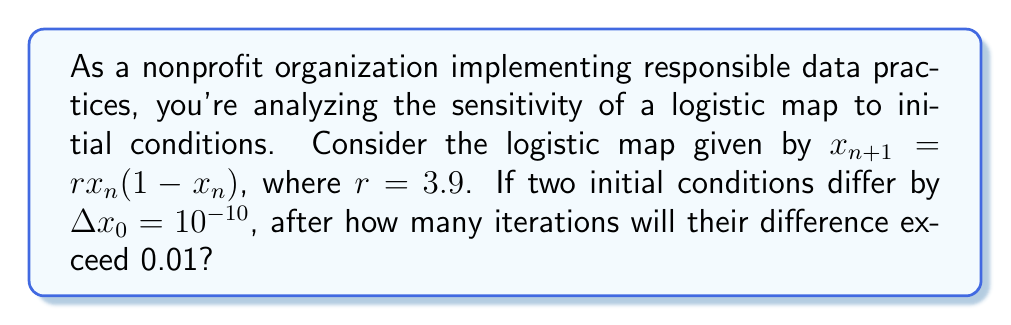What is the answer to this math problem? To solve this problem, we'll follow these steps:

1) The Lyapunov exponent $\lambda$ for the logistic map is given by:

   $$\lambda = \lim_{n\to\infty} \frac{1}{n} \sum_{i=0}^{n-1} \ln|r(1-2x_i)|$$

2) For $r = 3.9$, the Lyapunov exponent is approximately $\lambda \approx 0.6946$.

3) The difference between two nearby trajectories grows exponentially:

   $$\Delta x_n \approx \Delta x_0 e^{\lambda n}$$

4) We want to find $n$ when $\Delta x_n > 0.01$:

   $$0.01 = 10^{-10} e^{0.6946n}$$

5) Taking the natural log of both sides:

   $$\ln(0.01) = \ln(10^{-10}) + 0.6946n$$

6) Solving for $n$:

   $$n = \frac{\ln(0.01) - \ln(10^{-10})}{0.6946}$$

7) Calculating:

   $$n = \frac{\ln(10^{-2}) - \ln(10^{-10})}{0.6946} = \frac{8\ln(10)}{0.6946} \approx 26.54$$

8) Since we need the number of iterations to exceed 0.01, we round up to the next integer.
Answer: 27 iterations 